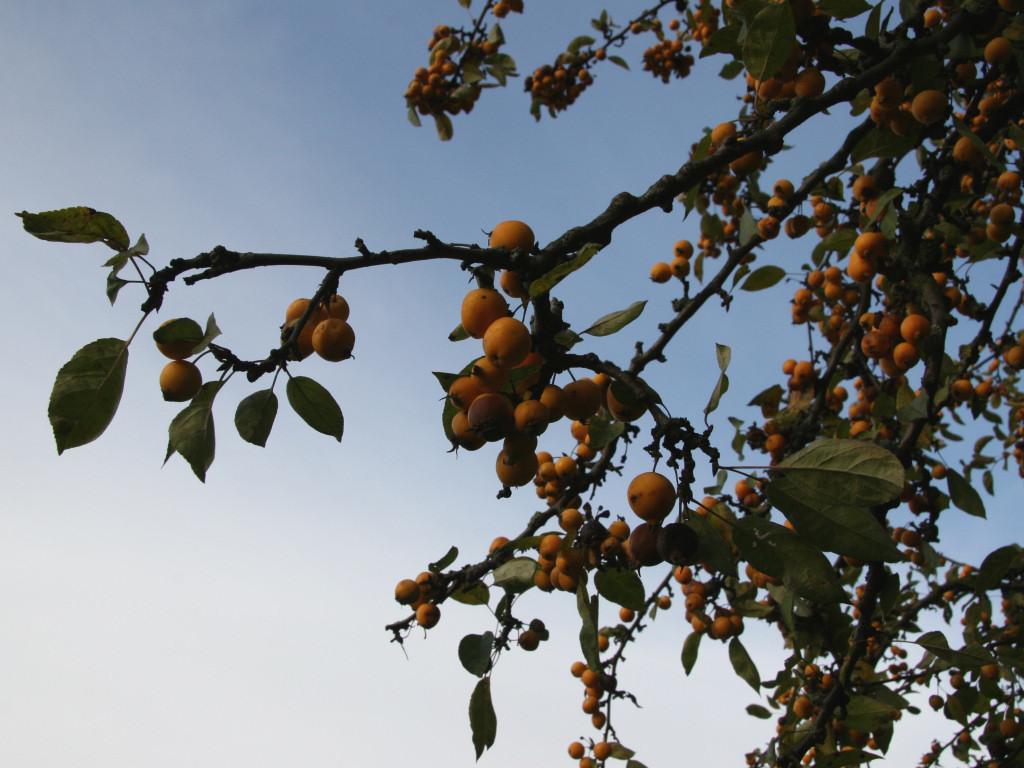Can you describe this image briefly? In this image, we can see fruits, stems and leaves. There is the sky in the background. 